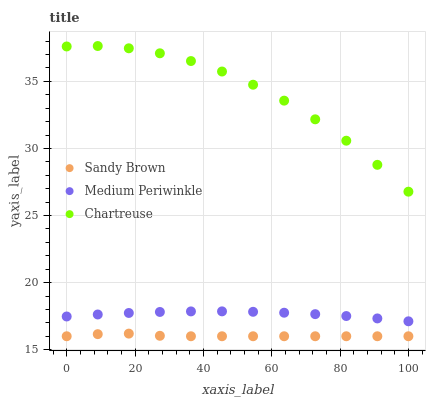Does Sandy Brown have the minimum area under the curve?
Answer yes or no. Yes. Does Chartreuse have the maximum area under the curve?
Answer yes or no. Yes. Does Chartreuse have the minimum area under the curve?
Answer yes or no. No. Does Sandy Brown have the maximum area under the curve?
Answer yes or no. No. Is Medium Periwinkle the smoothest?
Answer yes or no. Yes. Is Chartreuse the roughest?
Answer yes or no. Yes. Is Sandy Brown the smoothest?
Answer yes or no. No. Is Sandy Brown the roughest?
Answer yes or no. No. Does Sandy Brown have the lowest value?
Answer yes or no. Yes. Does Chartreuse have the lowest value?
Answer yes or no. No. Does Chartreuse have the highest value?
Answer yes or no. Yes. Does Sandy Brown have the highest value?
Answer yes or no. No. Is Sandy Brown less than Chartreuse?
Answer yes or no. Yes. Is Medium Periwinkle greater than Sandy Brown?
Answer yes or no. Yes. Does Sandy Brown intersect Chartreuse?
Answer yes or no. No. 